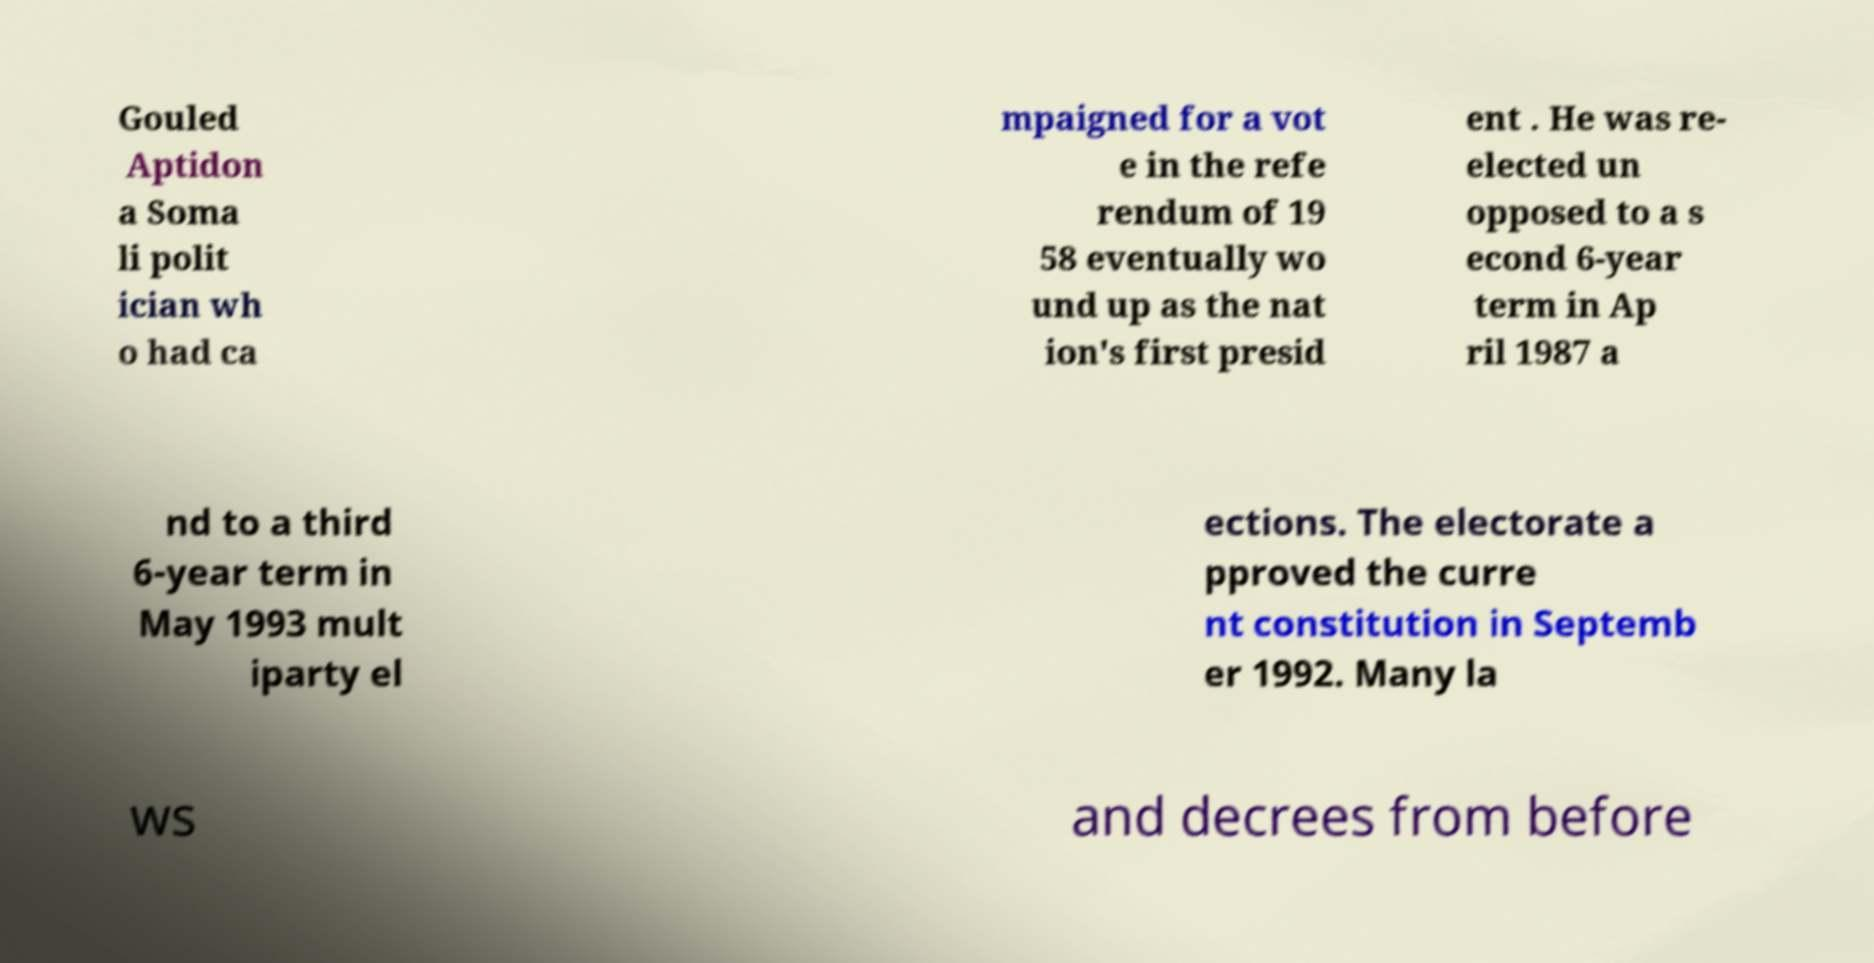Please identify and transcribe the text found in this image. Gouled Aptidon a Soma li polit ician wh o had ca mpaigned for a vot e in the refe rendum of 19 58 eventually wo und up as the nat ion's first presid ent . He was re- elected un opposed to a s econd 6-year term in Ap ril 1987 a nd to a third 6-year term in May 1993 mult iparty el ections. The electorate a pproved the curre nt constitution in Septemb er 1992. Many la ws and decrees from before 